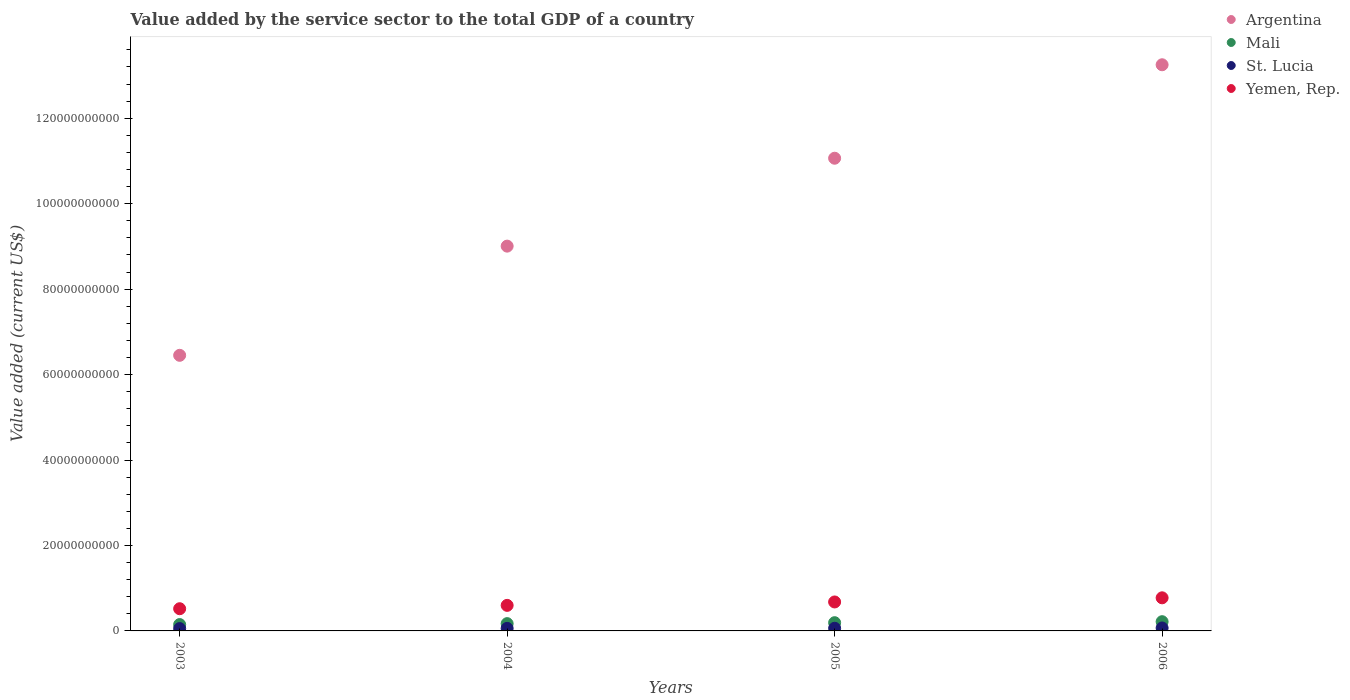Is the number of dotlines equal to the number of legend labels?
Your answer should be compact. Yes. What is the value added by the service sector to the total GDP in Argentina in 2003?
Provide a succinct answer. 6.45e+1. Across all years, what is the maximum value added by the service sector to the total GDP in Argentina?
Your answer should be very brief. 1.33e+11. Across all years, what is the minimum value added by the service sector to the total GDP in Yemen, Rep.?
Provide a short and direct response. 5.19e+09. In which year was the value added by the service sector to the total GDP in Mali minimum?
Ensure brevity in your answer.  2003. What is the total value added by the service sector to the total GDP in Argentina in the graph?
Give a very brief answer. 3.98e+11. What is the difference between the value added by the service sector to the total GDP in Argentina in 2003 and that in 2004?
Give a very brief answer. -2.56e+1. What is the difference between the value added by the service sector to the total GDP in Argentina in 2006 and the value added by the service sector to the total GDP in Yemen, Rep. in 2005?
Keep it short and to the point. 1.26e+11. What is the average value added by the service sector to the total GDP in Mali per year?
Ensure brevity in your answer.  1.82e+09. In the year 2004, what is the difference between the value added by the service sector to the total GDP in Mali and value added by the service sector to the total GDP in Yemen, Rep.?
Offer a very short reply. -4.27e+09. What is the ratio of the value added by the service sector to the total GDP in Yemen, Rep. in 2003 to that in 2005?
Ensure brevity in your answer.  0.77. What is the difference between the highest and the second highest value added by the service sector to the total GDP in Yemen, Rep.?
Keep it short and to the point. 9.69e+08. What is the difference between the highest and the lowest value added by the service sector to the total GDP in St. Lucia?
Your answer should be compact. 1.39e+08. Is it the case that in every year, the sum of the value added by the service sector to the total GDP in St. Lucia and value added by the service sector to the total GDP in Mali  is greater than the value added by the service sector to the total GDP in Yemen, Rep.?
Give a very brief answer. No. Is the value added by the service sector to the total GDP in Yemen, Rep. strictly greater than the value added by the service sector to the total GDP in St. Lucia over the years?
Your response must be concise. Yes. Is the value added by the service sector to the total GDP in Yemen, Rep. strictly less than the value added by the service sector to the total GDP in St. Lucia over the years?
Ensure brevity in your answer.  No. How many dotlines are there?
Offer a terse response. 4. How many years are there in the graph?
Give a very brief answer. 4. Are the values on the major ticks of Y-axis written in scientific E-notation?
Ensure brevity in your answer.  No. Does the graph contain any zero values?
Your response must be concise. No. Does the graph contain grids?
Ensure brevity in your answer.  No. Where does the legend appear in the graph?
Make the answer very short. Top right. How are the legend labels stacked?
Provide a succinct answer. Vertical. What is the title of the graph?
Offer a terse response. Value added by the service sector to the total GDP of a country. What is the label or title of the Y-axis?
Offer a very short reply. Value added (current US$). What is the Value added (current US$) in Argentina in 2003?
Ensure brevity in your answer.  6.45e+1. What is the Value added (current US$) in Mali in 2003?
Make the answer very short. 1.49e+09. What is the Value added (current US$) in St. Lucia in 2003?
Your response must be concise. 5.50e+08. What is the Value added (current US$) in Yemen, Rep. in 2003?
Ensure brevity in your answer.  5.19e+09. What is the Value added (current US$) in Argentina in 2004?
Keep it short and to the point. 9.01e+1. What is the Value added (current US$) in Mali in 2004?
Your answer should be compact. 1.71e+09. What is the Value added (current US$) in St. Lucia in 2004?
Your answer should be very brief. 5.94e+08. What is the Value added (current US$) of Yemen, Rep. in 2004?
Provide a short and direct response. 5.98e+09. What is the Value added (current US$) of Argentina in 2005?
Provide a short and direct response. 1.11e+11. What is the Value added (current US$) of Mali in 2005?
Your response must be concise. 1.93e+09. What is the Value added (current US$) of St. Lucia in 2005?
Your answer should be very brief. 6.24e+08. What is the Value added (current US$) of Yemen, Rep. in 2005?
Give a very brief answer. 6.78e+09. What is the Value added (current US$) of Argentina in 2006?
Provide a short and direct response. 1.33e+11. What is the Value added (current US$) in Mali in 2006?
Your response must be concise. 2.16e+09. What is the Value added (current US$) in St. Lucia in 2006?
Provide a succinct answer. 6.89e+08. What is the Value added (current US$) of Yemen, Rep. in 2006?
Your answer should be very brief. 7.75e+09. Across all years, what is the maximum Value added (current US$) of Argentina?
Make the answer very short. 1.33e+11. Across all years, what is the maximum Value added (current US$) in Mali?
Offer a very short reply. 2.16e+09. Across all years, what is the maximum Value added (current US$) of St. Lucia?
Give a very brief answer. 6.89e+08. Across all years, what is the maximum Value added (current US$) in Yemen, Rep.?
Your answer should be compact. 7.75e+09. Across all years, what is the minimum Value added (current US$) in Argentina?
Provide a succinct answer. 6.45e+1. Across all years, what is the minimum Value added (current US$) of Mali?
Make the answer very short. 1.49e+09. Across all years, what is the minimum Value added (current US$) of St. Lucia?
Provide a succinct answer. 5.50e+08. Across all years, what is the minimum Value added (current US$) of Yemen, Rep.?
Ensure brevity in your answer.  5.19e+09. What is the total Value added (current US$) in Argentina in the graph?
Offer a terse response. 3.98e+11. What is the total Value added (current US$) of Mali in the graph?
Your answer should be compact. 7.28e+09. What is the total Value added (current US$) in St. Lucia in the graph?
Your answer should be compact. 2.46e+09. What is the total Value added (current US$) in Yemen, Rep. in the graph?
Ensure brevity in your answer.  2.57e+1. What is the difference between the Value added (current US$) of Argentina in 2003 and that in 2004?
Give a very brief answer. -2.56e+1. What is the difference between the Value added (current US$) in Mali in 2003 and that in 2004?
Give a very brief answer. -2.21e+08. What is the difference between the Value added (current US$) in St. Lucia in 2003 and that in 2004?
Provide a succinct answer. -4.37e+07. What is the difference between the Value added (current US$) of Yemen, Rep. in 2003 and that in 2004?
Offer a terse response. -7.85e+08. What is the difference between the Value added (current US$) in Argentina in 2003 and that in 2005?
Your answer should be very brief. -4.61e+1. What is the difference between the Value added (current US$) in Mali in 2003 and that in 2005?
Your answer should be very brief. -4.42e+08. What is the difference between the Value added (current US$) in St. Lucia in 2003 and that in 2005?
Offer a terse response. -7.43e+07. What is the difference between the Value added (current US$) in Yemen, Rep. in 2003 and that in 2005?
Ensure brevity in your answer.  -1.58e+09. What is the difference between the Value added (current US$) in Argentina in 2003 and that in 2006?
Provide a succinct answer. -6.80e+1. What is the difference between the Value added (current US$) in Mali in 2003 and that in 2006?
Ensure brevity in your answer.  -6.75e+08. What is the difference between the Value added (current US$) of St. Lucia in 2003 and that in 2006?
Give a very brief answer. -1.39e+08. What is the difference between the Value added (current US$) in Yemen, Rep. in 2003 and that in 2006?
Your answer should be compact. -2.55e+09. What is the difference between the Value added (current US$) in Argentina in 2004 and that in 2005?
Your response must be concise. -2.06e+1. What is the difference between the Value added (current US$) of Mali in 2004 and that in 2005?
Offer a very short reply. -2.20e+08. What is the difference between the Value added (current US$) of St. Lucia in 2004 and that in 2005?
Offer a very short reply. -3.06e+07. What is the difference between the Value added (current US$) in Yemen, Rep. in 2004 and that in 2005?
Your answer should be very brief. -7.99e+08. What is the difference between the Value added (current US$) in Argentina in 2004 and that in 2006?
Provide a succinct answer. -4.24e+1. What is the difference between the Value added (current US$) of Mali in 2004 and that in 2006?
Your response must be concise. -4.54e+08. What is the difference between the Value added (current US$) in St. Lucia in 2004 and that in 2006?
Your answer should be compact. -9.55e+07. What is the difference between the Value added (current US$) in Yemen, Rep. in 2004 and that in 2006?
Offer a very short reply. -1.77e+09. What is the difference between the Value added (current US$) of Argentina in 2005 and that in 2006?
Provide a succinct answer. -2.19e+1. What is the difference between the Value added (current US$) in Mali in 2005 and that in 2006?
Make the answer very short. -2.34e+08. What is the difference between the Value added (current US$) in St. Lucia in 2005 and that in 2006?
Provide a short and direct response. -6.50e+07. What is the difference between the Value added (current US$) in Yemen, Rep. in 2005 and that in 2006?
Offer a very short reply. -9.69e+08. What is the difference between the Value added (current US$) of Argentina in 2003 and the Value added (current US$) of Mali in 2004?
Make the answer very short. 6.28e+1. What is the difference between the Value added (current US$) in Argentina in 2003 and the Value added (current US$) in St. Lucia in 2004?
Make the answer very short. 6.39e+1. What is the difference between the Value added (current US$) of Argentina in 2003 and the Value added (current US$) of Yemen, Rep. in 2004?
Your answer should be very brief. 5.85e+1. What is the difference between the Value added (current US$) in Mali in 2003 and the Value added (current US$) in St. Lucia in 2004?
Keep it short and to the point. 8.92e+08. What is the difference between the Value added (current US$) in Mali in 2003 and the Value added (current US$) in Yemen, Rep. in 2004?
Your response must be concise. -4.49e+09. What is the difference between the Value added (current US$) in St. Lucia in 2003 and the Value added (current US$) in Yemen, Rep. in 2004?
Offer a terse response. -5.43e+09. What is the difference between the Value added (current US$) in Argentina in 2003 and the Value added (current US$) in Mali in 2005?
Offer a terse response. 6.26e+1. What is the difference between the Value added (current US$) in Argentina in 2003 and the Value added (current US$) in St. Lucia in 2005?
Give a very brief answer. 6.39e+1. What is the difference between the Value added (current US$) of Argentina in 2003 and the Value added (current US$) of Yemen, Rep. in 2005?
Ensure brevity in your answer.  5.77e+1. What is the difference between the Value added (current US$) of Mali in 2003 and the Value added (current US$) of St. Lucia in 2005?
Provide a short and direct response. 8.61e+08. What is the difference between the Value added (current US$) of Mali in 2003 and the Value added (current US$) of Yemen, Rep. in 2005?
Provide a short and direct response. -5.29e+09. What is the difference between the Value added (current US$) in St. Lucia in 2003 and the Value added (current US$) in Yemen, Rep. in 2005?
Provide a succinct answer. -6.23e+09. What is the difference between the Value added (current US$) in Argentina in 2003 and the Value added (current US$) in Mali in 2006?
Ensure brevity in your answer.  6.23e+1. What is the difference between the Value added (current US$) of Argentina in 2003 and the Value added (current US$) of St. Lucia in 2006?
Give a very brief answer. 6.38e+1. What is the difference between the Value added (current US$) of Argentina in 2003 and the Value added (current US$) of Yemen, Rep. in 2006?
Provide a succinct answer. 5.68e+1. What is the difference between the Value added (current US$) of Mali in 2003 and the Value added (current US$) of St. Lucia in 2006?
Provide a succinct answer. 7.96e+08. What is the difference between the Value added (current US$) of Mali in 2003 and the Value added (current US$) of Yemen, Rep. in 2006?
Ensure brevity in your answer.  -6.26e+09. What is the difference between the Value added (current US$) in St. Lucia in 2003 and the Value added (current US$) in Yemen, Rep. in 2006?
Offer a terse response. -7.20e+09. What is the difference between the Value added (current US$) in Argentina in 2004 and the Value added (current US$) in Mali in 2005?
Give a very brief answer. 8.81e+1. What is the difference between the Value added (current US$) in Argentina in 2004 and the Value added (current US$) in St. Lucia in 2005?
Offer a very short reply. 8.94e+1. What is the difference between the Value added (current US$) of Argentina in 2004 and the Value added (current US$) of Yemen, Rep. in 2005?
Offer a very short reply. 8.33e+1. What is the difference between the Value added (current US$) of Mali in 2004 and the Value added (current US$) of St. Lucia in 2005?
Offer a terse response. 1.08e+09. What is the difference between the Value added (current US$) in Mali in 2004 and the Value added (current US$) in Yemen, Rep. in 2005?
Provide a short and direct response. -5.07e+09. What is the difference between the Value added (current US$) of St. Lucia in 2004 and the Value added (current US$) of Yemen, Rep. in 2005?
Provide a short and direct response. -6.19e+09. What is the difference between the Value added (current US$) of Argentina in 2004 and the Value added (current US$) of Mali in 2006?
Offer a terse response. 8.79e+1. What is the difference between the Value added (current US$) of Argentina in 2004 and the Value added (current US$) of St. Lucia in 2006?
Make the answer very short. 8.94e+1. What is the difference between the Value added (current US$) of Argentina in 2004 and the Value added (current US$) of Yemen, Rep. in 2006?
Offer a terse response. 8.23e+1. What is the difference between the Value added (current US$) in Mali in 2004 and the Value added (current US$) in St. Lucia in 2006?
Offer a terse response. 1.02e+09. What is the difference between the Value added (current US$) in Mali in 2004 and the Value added (current US$) in Yemen, Rep. in 2006?
Offer a very short reply. -6.04e+09. What is the difference between the Value added (current US$) in St. Lucia in 2004 and the Value added (current US$) in Yemen, Rep. in 2006?
Provide a short and direct response. -7.15e+09. What is the difference between the Value added (current US$) in Argentina in 2005 and the Value added (current US$) in Mali in 2006?
Your answer should be compact. 1.08e+11. What is the difference between the Value added (current US$) in Argentina in 2005 and the Value added (current US$) in St. Lucia in 2006?
Provide a succinct answer. 1.10e+11. What is the difference between the Value added (current US$) of Argentina in 2005 and the Value added (current US$) of Yemen, Rep. in 2006?
Provide a short and direct response. 1.03e+11. What is the difference between the Value added (current US$) in Mali in 2005 and the Value added (current US$) in St. Lucia in 2006?
Offer a terse response. 1.24e+09. What is the difference between the Value added (current US$) of Mali in 2005 and the Value added (current US$) of Yemen, Rep. in 2006?
Your answer should be very brief. -5.82e+09. What is the difference between the Value added (current US$) of St. Lucia in 2005 and the Value added (current US$) of Yemen, Rep. in 2006?
Your answer should be compact. -7.12e+09. What is the average Value added (current US$) of Argentina per year?
Provide a succinct answer. 9.94e+1. What is the average Value added (current US$) of Mali per year?
Offer a very short reply. 1.82e+09. What is the average Value added (current US$) of St. Lucia per year?
Keep it short and to the point. 6.14e+08. What is the average Value added (current US$) in Yemen, Rep. per year?
Offer a very short reply. 6.43e+09. In the year 2003, what is the difference between the Value added (current US$) in Argentina and Value added (current US$) in Mali?
Your response must be concise. 6.30e+1. In the year 2003, what is the difference between the Value added (current US$) in Argentina and Value added (current US$) in St. Lucia?
Make the answer very short. 6.40e+1. In the year 2003, what is the difference between the Value added (current US$) of Argentina and Value added (current US$) of Yemen, Rep.?
Ensure brevity in your answer.  5.93e+1. In the year 2003, what is the difference between the Value added (current US$) in Mali and Value added (current US$) in St. Lucia?
Your answer should be compact. 9.35e+08. In the year 2003, what is the difference between the Value added (current US$) in Mali and Value added (current US$) in Yemen, Rep.?
Offer a very short reply. -3.71e+09. In the year 2003, what is the difference between the Value added (current US$) of St. Lucia and Value added (current US$) of Yemen, Rep.?
Make the answer very short. -4.64e+09. In the year 2004, what is the difference between the Value added (current US$) in Argentina and Value added (current US$) in Mali?
Your answer should be compact. 8.84e+1. In the year 2004, what is the difference between the Value added (current US$) of Argentina and Value added (current US$) of St. Lucia?
Offer a very short reply. 8.95e+1. In the year 2004, what is the difference between the Value added (current US$) in Argentina and Value added (current US$) in Yemen, Rep.?
Ensure brevity in your answer.  8.41e+1. In the year 2004, what is the difference between the Value added (current US$) in Mali and Value added (current US$) in St. Lucia?
Provide a short and direct response. 1.11e+09. In the year 2004, what is the difference between the Value added (current US$) in Mali and Value added (current US$) in Yemen, Rep.?
Ensure brevity in your answer.  -4.27e+09. In the year 2004, what is the difference between the Value added (current US$) in St. Lucia and Value added (current US$) in Yemen, Rep.?
Keep it short and to the point. -5.39e+09. In the year 2005, what is the difference between the Value added (current US$) in Argentina and Value added (current US$) in Mali?
Your response must be concise. 1.09e+11. In the year 2005, what is the difference between the Value added (current US$) in Argentina and Value added (current US$) in St. Lucia?
Give a very brief answer. 1.10e+11. In the year 2005, what is the difference between the Value added (current US$) in Argentina and Value added (current US$) in Yemen, Rep.?
Offer a very short reply. 1.04e+11. In the year 2005, what is the difference between the Value added (current US$) of Mali and Value added (current US$) of St. Lucia?
Give a very brief answer. 1.30e+09. In the year 2005, what is the difference between the Value added (current US$) in Mali and Value added (current US$) in Yemen, Rep.?
Provide a succinct answer. -4.85e+09. In the year 2005, what is the difference between the Value added (current US$) in St. Lucia and Value added (current US$) in Yemen, Rep.?
Offer a very short reply. -6.15e+09. In the year 2006, what is the difference between the Value added (current US$) of Argentina and Value added (current US$) of Mali?
Keep it short and to the point. 1.30e+11. In the year 2006, what is the difference between the Value added (current US$) in Argentina and Value added (current US$) in St. Lucia?
Offer a terse response. 1.32e+11. In the year 2006, what is the difference between the Value added (current US$) in Argentina and Value added (current US$) in Yemen, Rep.?
Give a very brief answer. 1.25e+11. In the year 2006, what is the difference between the Value added (current US$) in Mali and Value added (current US$) in St. Lucia?
Your response must be concise. 1.47e+09. In the year 2006, what is the difference between the Value added (current US$) in Mali and Value added (current US$) in Yemen, Rep.?
Offer a very short reply. -5.59e+09. In the year 2006, what is the difference between the Value added (current US$) in St. Lucia and Value added (current US$) in Yemen, Rep.?
Offer a very short reply. -7.06e+09. What is the ratio of the Value added (current US$) of Argentina in 2003 to that in 2004?
Your response must be concise. 0.72. What is the ratio of the Value added (current US$) in Mali in 2003 to that in 2004?
Your answer should be compact. 0.87. What is the ratio of the Value added (current US$) in St. Lucia in 2003 to that in 2004?
Provide a succinct answer. 0.93. What is the ratio of the Value added (current US$) in Yemen, Rep. in 2003 to that in 2004?
Offer a very short reply. 0.87. What is the ratio of the Value added (current US$) in Argentina in 2003 to that in 2005?
Your answer should be very brief. 0.58. What is the ratio of the Value added (current US$) in Mali in 2003 to that in 2005?
Your answer should be compact. 0.77. What is the ratio of the Value added (current US$) in St. Lucia in 2003 to that in 2005?
Give a very brief answer. 0.88. What is the ratio of the Value added (current US$) of Yemen, Rep. in 2003 to that in 2005?
Offer a very short reply. 0.77. What is the ratio of the Value added (current US$) of Argentina in 2003 to that in 2006?
Keep it short and to the point. 0.49. What is the ratio of the Value added (current US$) in Mali in 2003 to that in 2006?
Give a very brief answer. 0.69. What is the ratio of the Value added (current US$) of St. Lucia in 2003 to that in 2006?
Provide a short and direct response. 0.8. What is the ratio of the Value added (current US$) of Yemen, Rep. in 2003 to that in 2006?
Give a very brief answer. 0.67. What is the ratio of the Value added (current US$) in Argentina in 2004 to that in 2005?
Provide a succinct answer. 0.81. What is the ratio of the Value added (current US$) in Mali in 2004 to that in 2005?
Your answer should be compact. 0.89. What is the ratio of the Value added (current US$) in St. Lucia in 2004 to that in 2005?
Give a very brief answer. 0.95. What is the ratio of the Value added (current US$) in Yemen, Rep. in 2004 to that in 2005?
Your answer should be compact. 0.88. What is the ratio of the Value added (current US$) of Argentina in 2004 to that in 2006?
Offer a terse response. 0.68. What is the ratio of the Value added (current US$) of Mali in 2004 to that in 2006?
Keep it short and to the point. 0.79. What is the ratio of the Value added (current US$) in St. Lucia in 2004 to that in 2006?
Provide a short and direct response. 0.86. What is the ratio of the Value added (current US$) in Yemen, Rep. in 2004 to that in 2006?
Make the answer very short. 0.77. What is the ratio of the Value added (current US$) of Argentina in 2005 to that in 2006?
Your answer should be compact. 0.83. What is the ratio of the Value added (current US$) of Mali in 2005 to that in 2006?
Ensure brevity in your answer.  0.89. What is the ratio of the Value added (current US$) of St. Lucia in 2005 to that in 2006?
Keep it short and to the point. 0.91. What is the ratio of the Value added (current US$) in Yemen, Rep. in 2005 to that in 2006?
Provide a succinct answer. 0.87. What is the difference between the highest and the second highest Value added (current US$) of Argentina?
Make the answer very short. 2.19e+1. What is the difference between the highest and the second highest Value added (current US$) of Mali?
Your answer should be compact. 2.34e+08. What is the difference between the highest and the second highest Value added (current US$) in St. Lucia?
Provide a succinct answer. 6.50e+07. What is the difference between the highest and the second highest Value added (current US$) of Yemen, Rep.?
Give a very brief answer. 9.69e+08. What is the difference between the highest and the lowest Value added (current US$) of Argentina?
Make the answer very short. 6.80e+1. What is the difference between the highest and the lowest Value added (current US$) of Mali?
Your answer should be compact. 6.75e+08. What is the difference between the highest and the lowest Value added (current US$) of St. Lucia?
Provide a succinct answer. 1.39e+08. What is the difference between the highest and the lowest Value added (current US$) of Yemen, Rep.?
Give a very brief answer. 2.55e+09. 